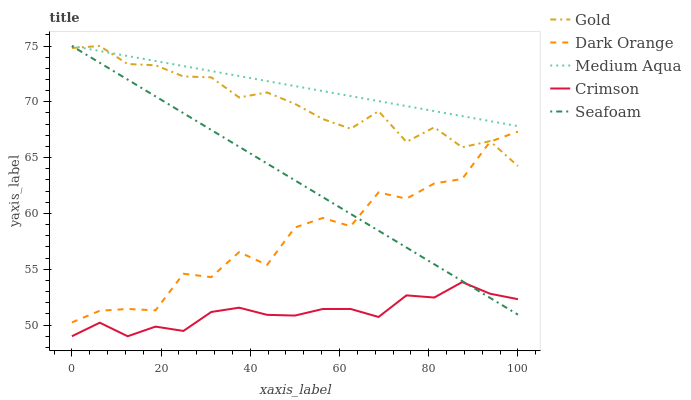Does Crimson have the minimum area under the curve?
Answer yes or no. Yes. Does Medium Aqua have the maximum area under the curve?
Answer yes or no. Yes. Does Dark Orange have the minimum area under the curve?
Answer yes or no. No. Does Dark Orange have the maximum area under the curve?
Answer yes or no. No. Is Seafoam the smoothest?
Answer yes or no. Yes. Is Dark Orange the roughest?
Answer yes or no. Yes. Is Medium Aqua the smoothest?
Answer yes or no. No. Is Medium Aqua the roughest?
Answer yes or no. No. Does Crimson have the lowest value?
Answer yes or no. Yes. Does Dark Orange have the lowest value?
Answer yes or no. No. Does Gold have the highest value?
Answer yes or no. Yes. Does Dark Orange have the highest value?
Answer yes or no. No. Is Crimson less than Gold?
Answer yes or no. Yes. Is Gold greater than Crimson?
Answer yes or no. Yes. Does Seafoam intersect Crimson?
Answer yes or no. Yes. Is Seafoam less than Crimson?
Answer yes or no. No. Is Seafoam greater than Crimson?
Answer yes or no. No. Does Crimson intersect Gold?
Answer yes or no. No. 